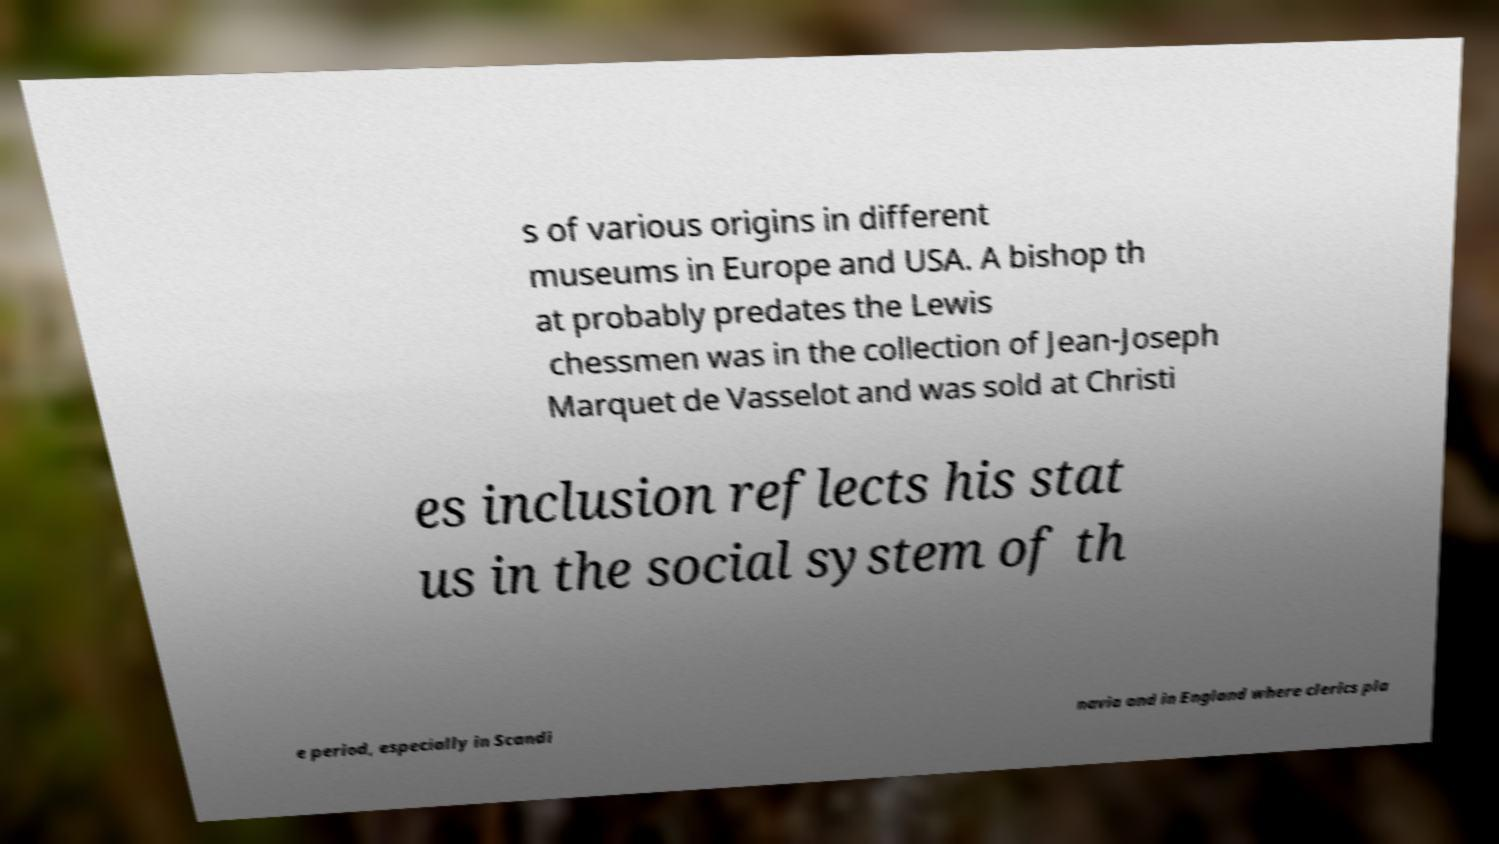What messages or text are displayed in this image? I need them in a readable, typed format. s of various origins in different museums in Europe and USA. A bishop th at probably predates the Lewis chessmen was in the collection of Jean-Joseph Marquet de Vasselot and was sold at Christi es inclusion reflects his stat us in the social system of th e period, especially in Scandi navia and in England where clerics pla 